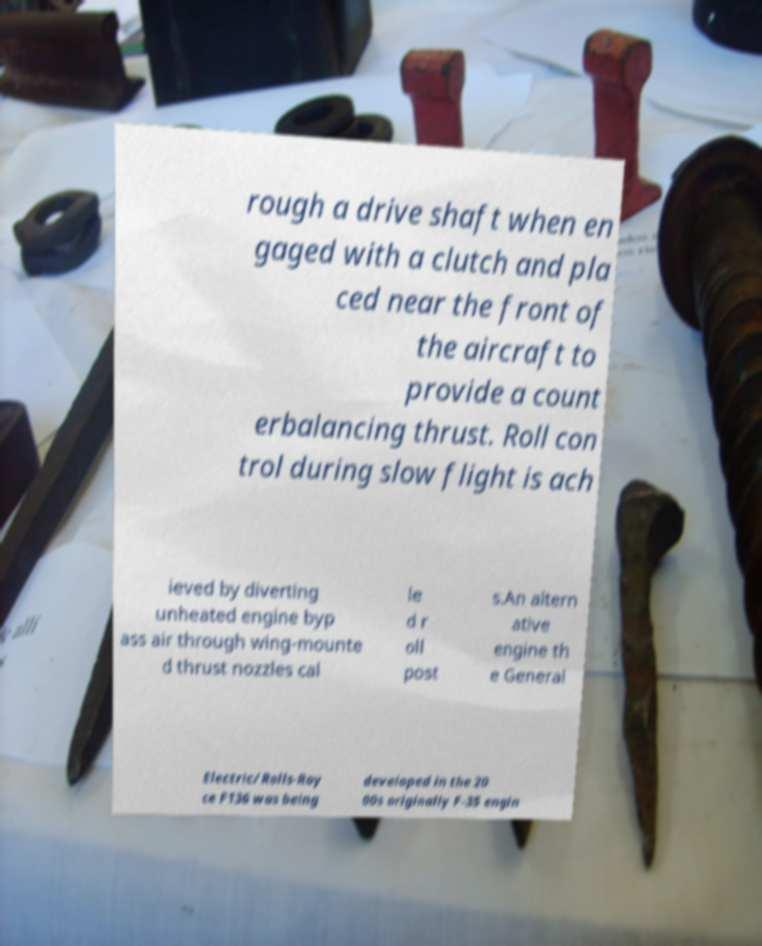Can you accurately transcribe the text from the provided image for me? rough a drive shaft when en gaged with a clutch and pla ced near the front of the aircraft to provide a count erbalancing thrust. Roll con trol during slow flight is ach ieved by diverting unheated engine byp ass air through wing-mounte d thrust nozzles cal le d r oll post s.An altern ative engine th e General Electric/Rolls-Roy ce F136 was being developed in the 20 00s originally F-35 engin 